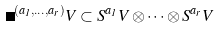<formula> <loc_0><loc_0><loc_500><loc_500>\Gamma ^ { ( a _ { 1 } , \dots , a _ { r } ) } V \subset S ^ { a _ { 1 } } V \otimes \dots \otimes S ^ { a _ { r } } V</formula> 